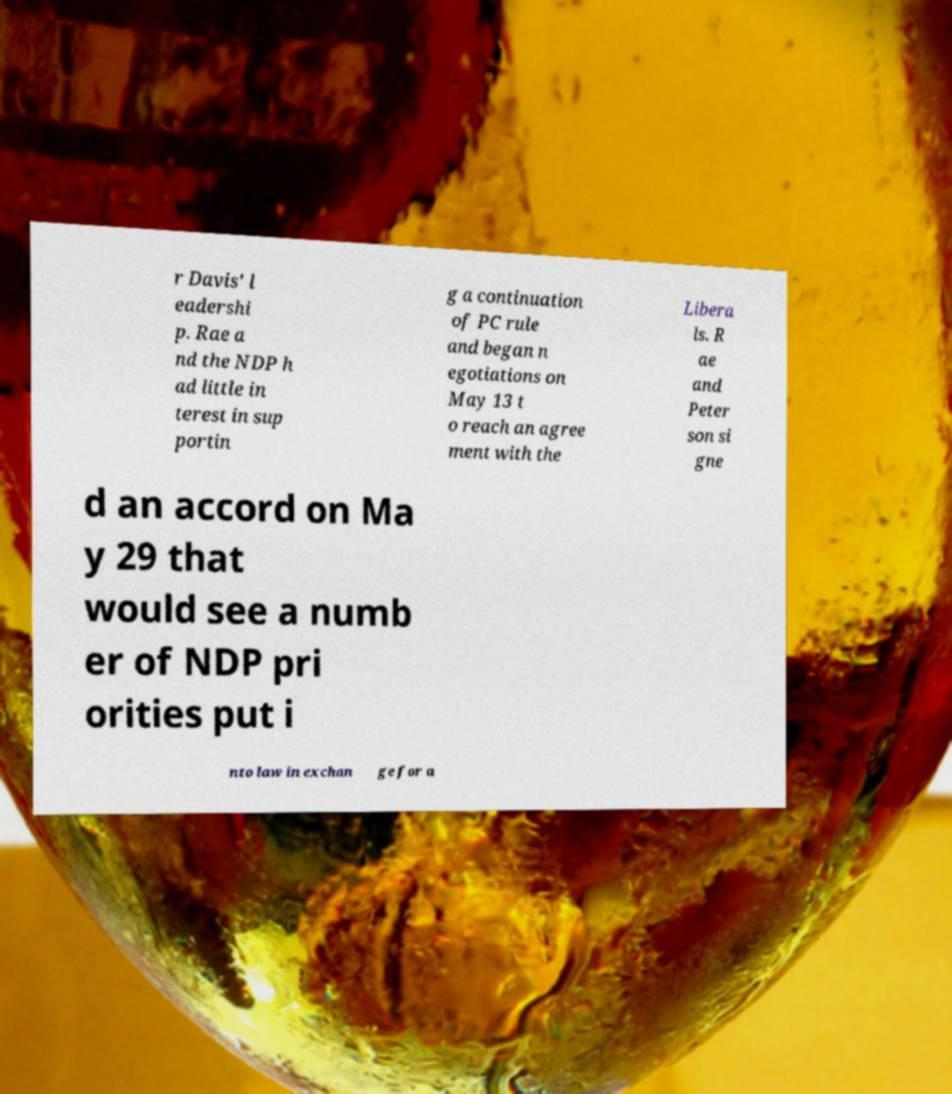Could you extract and type out the text from this image? r Davis' l eadershi p. Rae a nd the NDP h ad little in terest in sup portin g a continuation of PC rule and began n egotiations on May 13 t o reach an agree ment with the Libera ls. R ae and Peter son si gne d an accord on Ma y 29 that would see a numb er of NDP pri orities put i nto law in exchan ge for a 